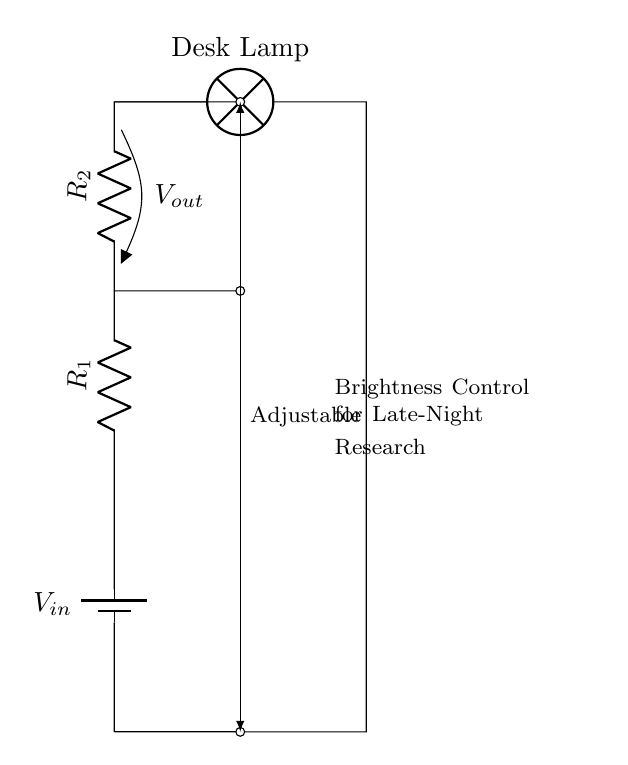What is the input voltage in this circuit? The input voltage is represented as V_in, which indicates the voltage supplied to the circuit from the battery.
Answer: V_in What type of resistors are used in this circuit? The circuit uses two resistors in series, designated as R_1 and R_2, typically used for voltage division in circuits.
Answer: Resistors What is the function of R_1 in this circuit? R_1 is used as part of the voltage divider to drop voltage; it works with R_2 to adjust the brightness of the lamp.
Answer: Voltage drop How can the output voltage be adjusted in this circuit? The output voltage can be adjusted by changing the values of R_1 and R_2 or by using a variable resistor, manipulating the voltage divider concept.
Answer: By changing resistors What is the significance of V_out in this circuit? V_out represents the voltage across R_2, which directly affects the brightness of the lamp. As V_out changes, so does the brightness of the desk lamp used for research.
Answer: Brightness control What would happen if R_2 was removed from the circuit? If R_2 is removed, there will be no output voltage available to the lamp, resulting in no light being produced since the voltage divider relies on both resistors for operation.
Answer: No light 